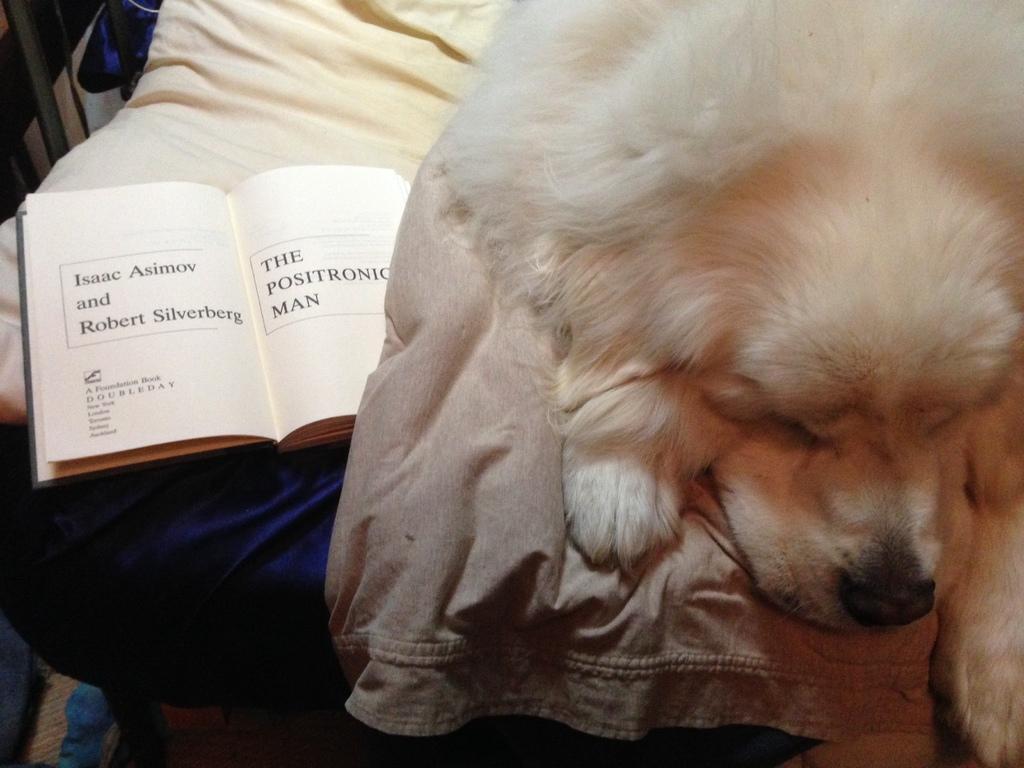Please provide a concise description of this image. In this picture we can see a dog, cloth and book on the bed and objects. 